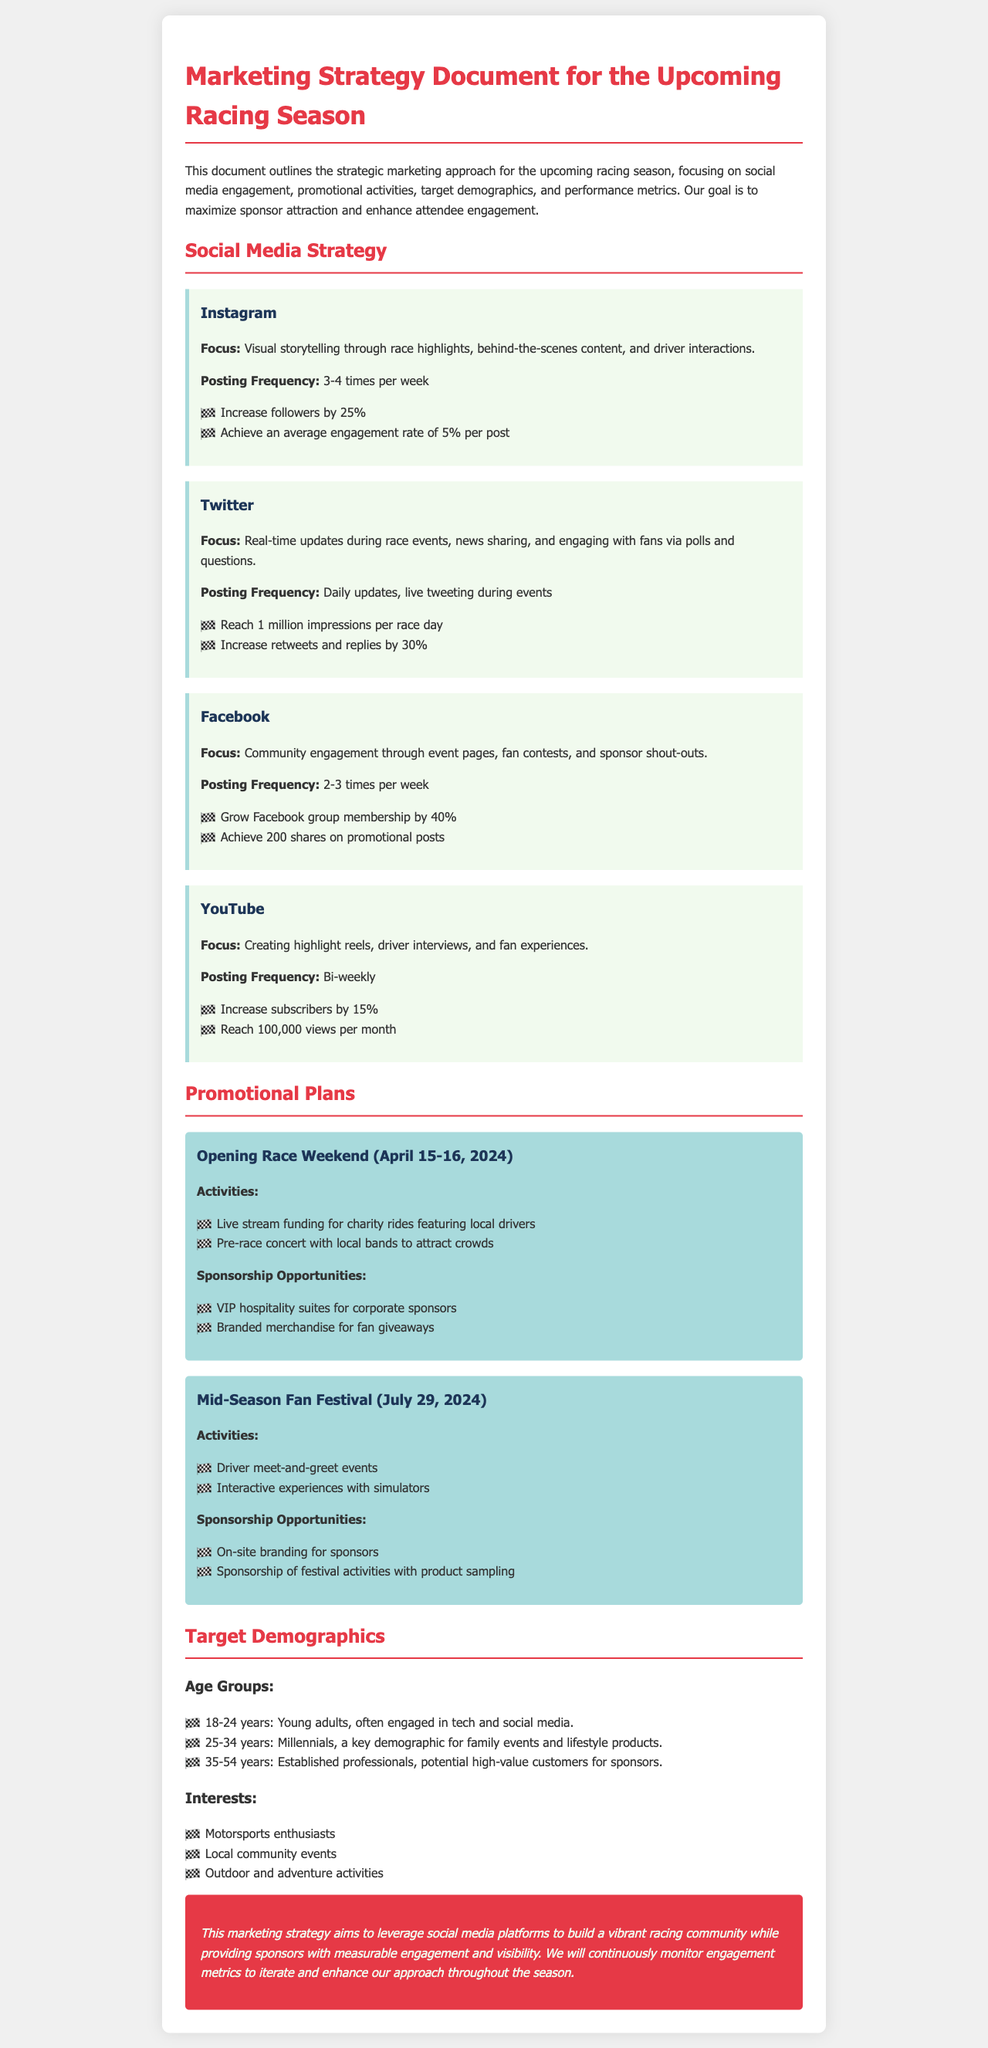What is the focus of the Instagram strategy? The Instagram strategy focuses on visual storytelling through race highlights, behind-the-scenes content, and driver interactions.
Answer: Visual storytelling How often will Twitter be updated? The document states that Twitter will have daily updates and live tweeting during events.
Answer: Daily updates What is the goal for follower increase on Instagram? The document specifies an increase of 25% in followers on Instagram.
Answer: 25% What activities are planned for the Opening Race Weekend? Activities for the Opening Race Weekend include live stream funding for charity rides featuring local drivers and a pre-race concert with local bands.
Answer: Live stream funding for charity rides and pre-race concert What is the target engagement rate per post on Instagram? The target engagement rate per post on Instagram is stated to be 5%.
Answer: 5% How many times per week will Facebook be updated? The document mentions that Facebook will be updated 2-3 times per week.
Answer: 2-3 times What age group is identified as being between 18-24 years old? The document identifies this group as young adults, often engaged in tech and social media.
Answer: Young adults What sponsorship opportunity is mentioned for the Mid-Season Fan Festival? The document lists on-site branding for sponsors as a sponsorship opportunity for the Mid-Season Fan Festival.
Answer: On-site branding 